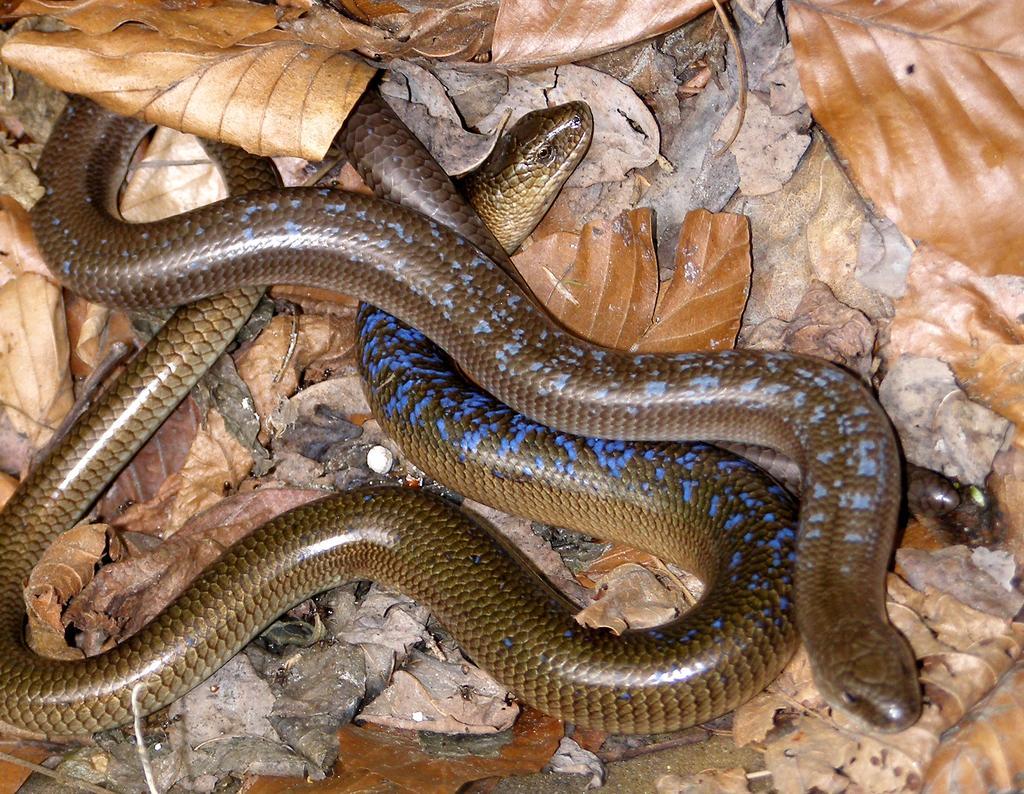Can you describe this image briefly? In this picture we can see snakes on the ground and in the background we can see dried leaves. 